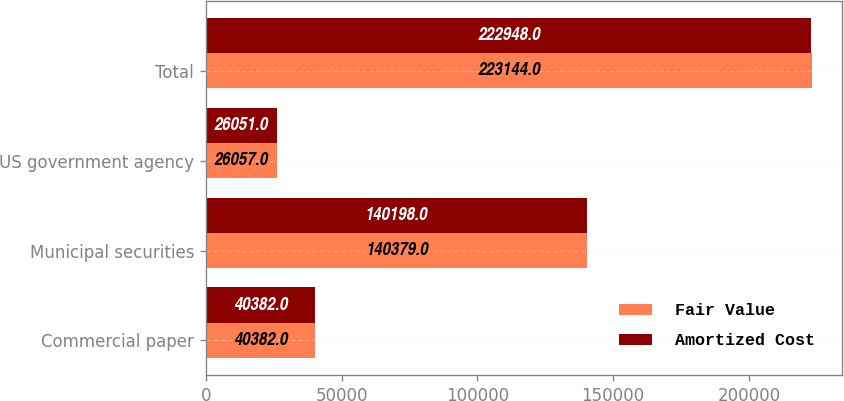Convert chart. <chart><loc_0><loc_0><loc_500><loc_500><stacked_bar_chart><ecel><fcel>Commercial paper<fcel>Municipal securities<fcel>US government agency<fcel>Total<nl><fcel>Fair Value<fcel>40382<fcel>140379<fcel>26057<fcel>223144<nl><fcel>Amortized Cost<fcel>40382<fcel>140198<fcel>26051<fcel>222948<nl></chart> 